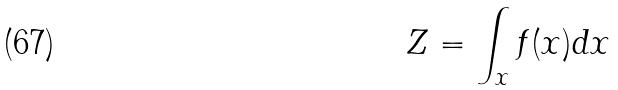<formula> <loc_0><loc_0><loc_500><loc_500>Z = \int _ { x } f ( x ) d x</formula> 